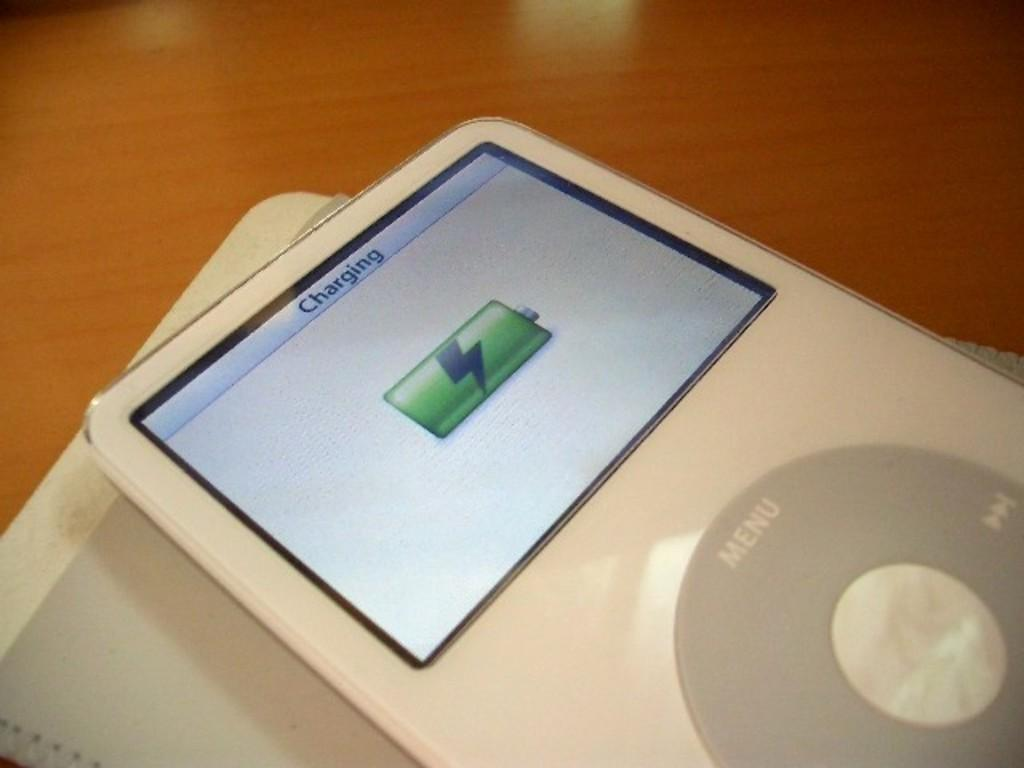What object is present in the image that can be considered a gadget? There is a gadget in the image. What is the status of the gadget's battery in the image? The gadget is fully charged. What is the gadget placed on in the image? The gadget is placed on a book. What surface is the book resting on in the image? There is a table under the book. How many rabbits are hopping on the bed in the image? There are no rabbits or beds present in the image. 